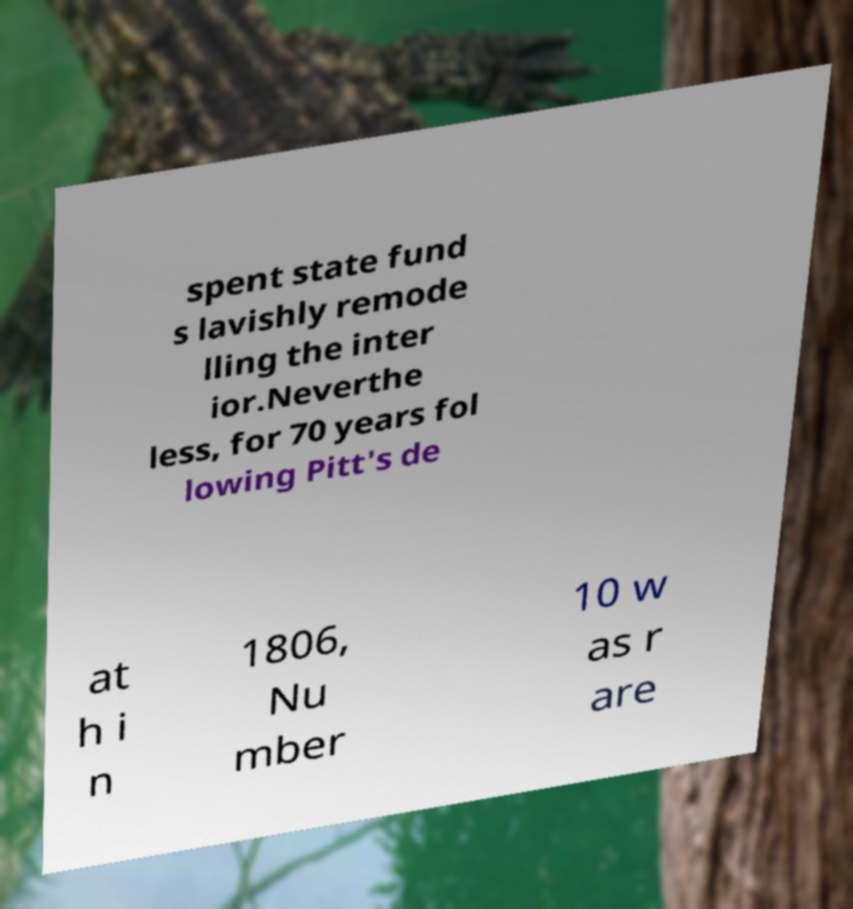Please read and relay the text visible in this image. What does it say? spent state fund s lavishly remode lling the inter ior.Neverthe less, for 70 years fol lowing Pitt's de at h i n 1806, Nu mber 10 w as r are 